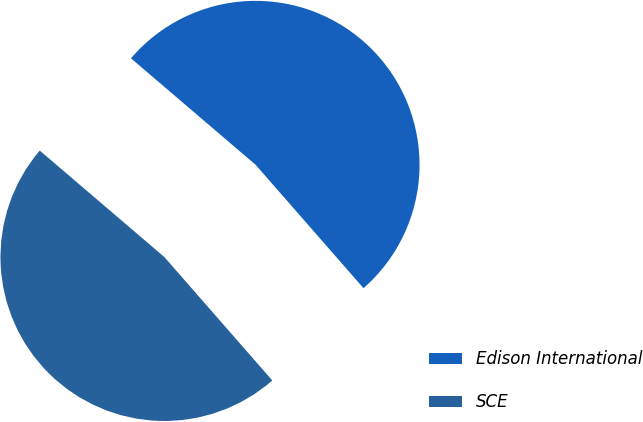Convert chart. <chart><loc_0><loc_0><loc_500><loc_500><pie_chart><fcel>Edison International<fcel>SCE<nl><fcel>52.31%<fcel>47.69%<nl></chart> 